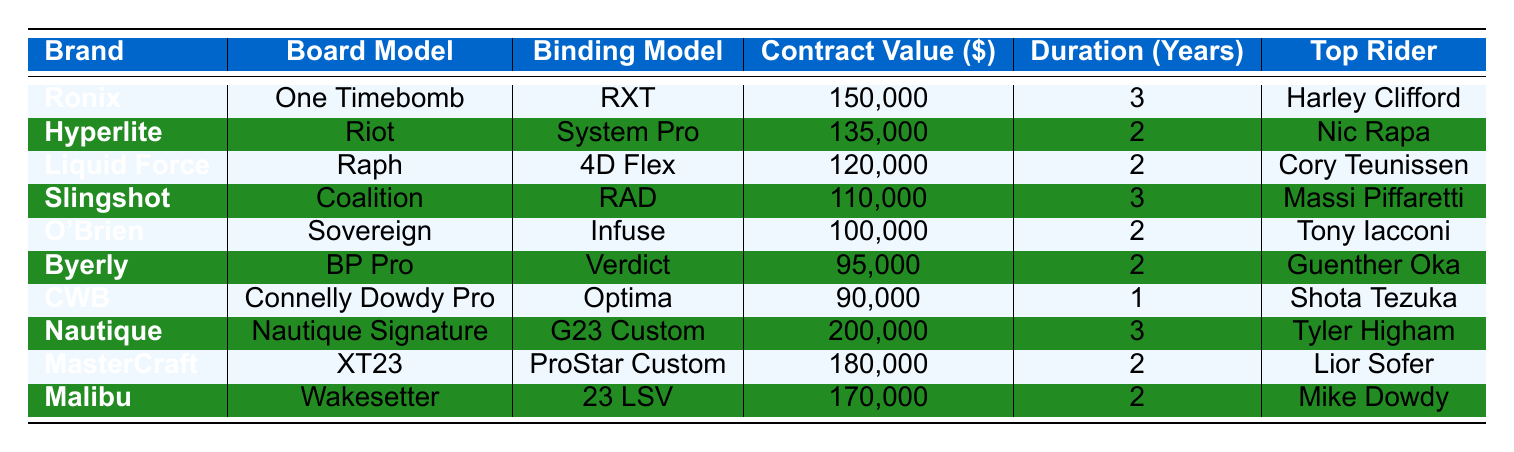What is the highest contract value among the sponsorships? The table lists the contract values for each sponsorship deal. The highest contract value is observed next to the Nautique brand, which is $200,000.
Answer: $200,000 Which rider is sponsored by Liquid Force? The table shows that Cory Teunissen is associated with the Liquid Force brand.
Answer: Cory Teunissen How many riders have contracts with a duration of 2 years? By reviewing the table, we see that four riders (Nic Rapa, Cory Teunissen, O'Brien, and MasterCraft) have contracts with a duration of 2 years.
Answer: 4 What is the total contract value of all the sponsorship deals listed? By adding all the contract values: 150,000 + 135,000 + 120,000 + 110,000 + 100,000 + 95,000 + 90,000 + 200,000 + 180,000 + 170,000, we find the total equals 1,350,000.
Answer: $1,350,000 Does any rider have a sponsorship deal with a contract value less than $100,000? Reviewing the table, we see that CWB's contract value is $90,000, which is less than $100,000. Thus, the answer is yes.
Answer: Yes Which brands have contracts with a duration of 3 years, and who is their top rider? Looking at the table, Ronix and Nautique both have contracts lasting 3 years. Their top riders are Harley Clifford and Tyler Higham, respectively.
Answer: Ronix - Harley Clifford, Nautique - Tyler Higham What is the average contract value for the sponsorships with a duration of 2 years? The contract values for 2-year deals are 135,000, 120,000, 100,000, 95,000, 180,000, and 170,000. The sum is 900,000, and since there are 6 deals, the average is 900,000 / 6 = 150,000.
Answer: $150,000 Which rider has the highest contract value and what brand is associated with it? The highest contract value is $200,000, which is associated with Tyler Higham and Nautique.
Answer: Tyler Higham - Nautique Are there any riders who have sponsorships with different brands but similar contract values? Examining the table, we see that MasterCraft ($180,000) and Malibu ($170,000) are close but not the same; hence, there are no riders with exactly similar contract values across different brands.
Answer: No What is the difference in contract value between the highest and lowest sponsorship deals? The highest contract value is $200,000 (Nautique), and the lowest is $90,000 (CWB). The difference is 200,000 - 90,000 = 110,000.
Answer: $110,000 